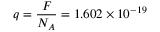<formula> <loc_0><loc_0><loc_500><loc_500>q = \frac { F } { N _ { A } } = 1 . 6 0 2 \times 1 0 ^ { - 1 9 }</formula> 